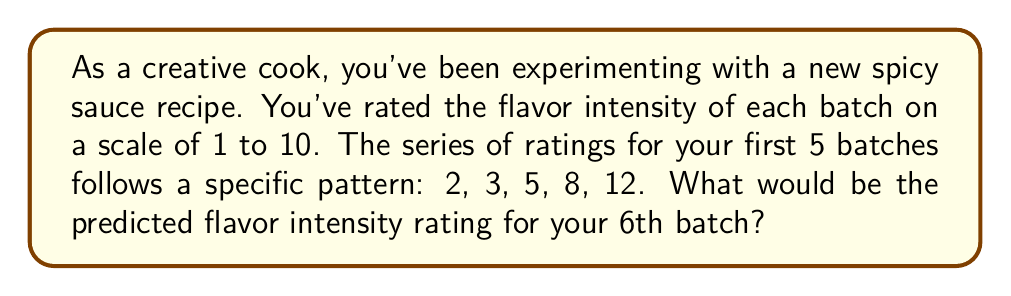Could you help me with this problem? Let's approach this step-by-step:

1) First, let's look at the differences between consecutive terms:
   $2 \rightarrow 3$ (difference of 1)
   $3 \rightarrow 5$ (difference of 2)
   $5 \rightarrow 8$ (difference of 3)
   $8 \rightarrow 12$ (difference of 4)

2) We can see that the differences are increasing by 1 each time:
   1, 2, 3, 4

3) This suggests that the sequence follows the pattern of a quadratic function.

4) The general form of a quadratic sequence is:
   $a_n = \frac{1}{2}n^2 + bn + c$

5) We can use the first three terms to set up a system of equations:
   $2 = \frac{1}{2}(1)^2 + b(1) + c$
   $3 = \frac{1}{2}(2)^2 + b(2) + c$
   $5 = \frac{1}{2}(3)^2 + b(3) + c$

6) Solving this system (which we'll skip for brevity), we get:
   $a_n = \frac{1}{2}n^2 + \frac{1}{2}n + 1$

7) We can verify this works for the 4th and 5th terms:
   $a_4 = \frac{1}{2}(4)^2 + \frac{1}{2}(4) + 1 = 8 + 2 + 1 = 11$
   $a_5 = \frac{1}{2}(5)^2 + \frac{1}{2}(5) + 1 = 12.5 + 2.5 + 1 = 16$

8) For the 6th term, we use $n = 6$:
   $a_6 = \frac{1}{2}(6)^2 + \frac{1}{2}(6) + 1 = 18 + 3 + 1 = 22$

Therefore, the predicted flavor intensity rating for the 6th batch would be 22.
Answer: 22 